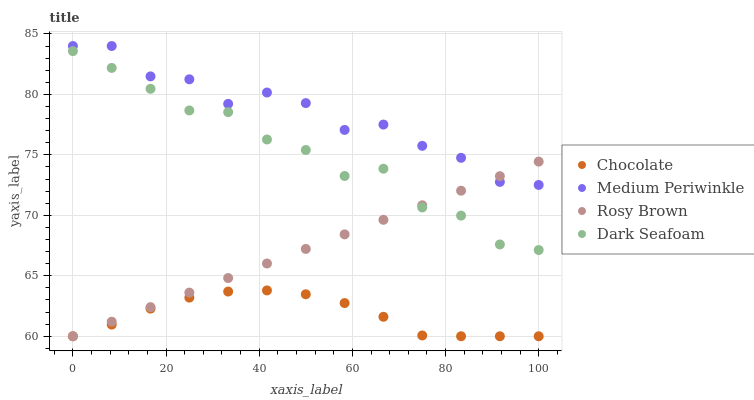Does Chocolate have the minimum area under the curve?
Answer yes or no. Yes. Does Medium Periwinkle have the maximum area under the curve?
Answer yes or no. Yes. Does Rosy Brown have the minimum area under the curve?
Answer yes or no. No. Does Rosy Brown have the maximum area under the curve?
Answer yes or no. No. Is Rosy Brown the smoothest?
Answer yes or no. Yes. Is Medium Periwinkle the roughest?
Answer yes or no. Yes. Is Medium Periwinkle the smoothest?
Answer yes or no. No. Is Rosy Brown the roughest?
Answer yes or no. No. Does Rosy Brown have the lowest value?
Answer yes or no. Yes. Does Medium Periwinkle have the lowest value?
Answer yes or no. No. Does Medium Periwinkle have the highest value?
Answer yes or no. Yes. Does Rosy Brown have the highest value?
Answer yes or no. No. Is Chocolate less than Medium Periwinkle?
Answer yes or no. Yes. Is Medium Periwinkle greater than Dark Seafoam?
Answer yes or no. Yes. Does Rosy Brown intersect Chocolate?
Answer yes or no. Yes. Is Rosy Brown less than Chocolate?
Answer yes or no. No. Is Rosy Brown greater than Chocolate?
Answer yes or no. No. Does Chocolate intersect Medium Periwinkle?
Answer yes or no. No. 